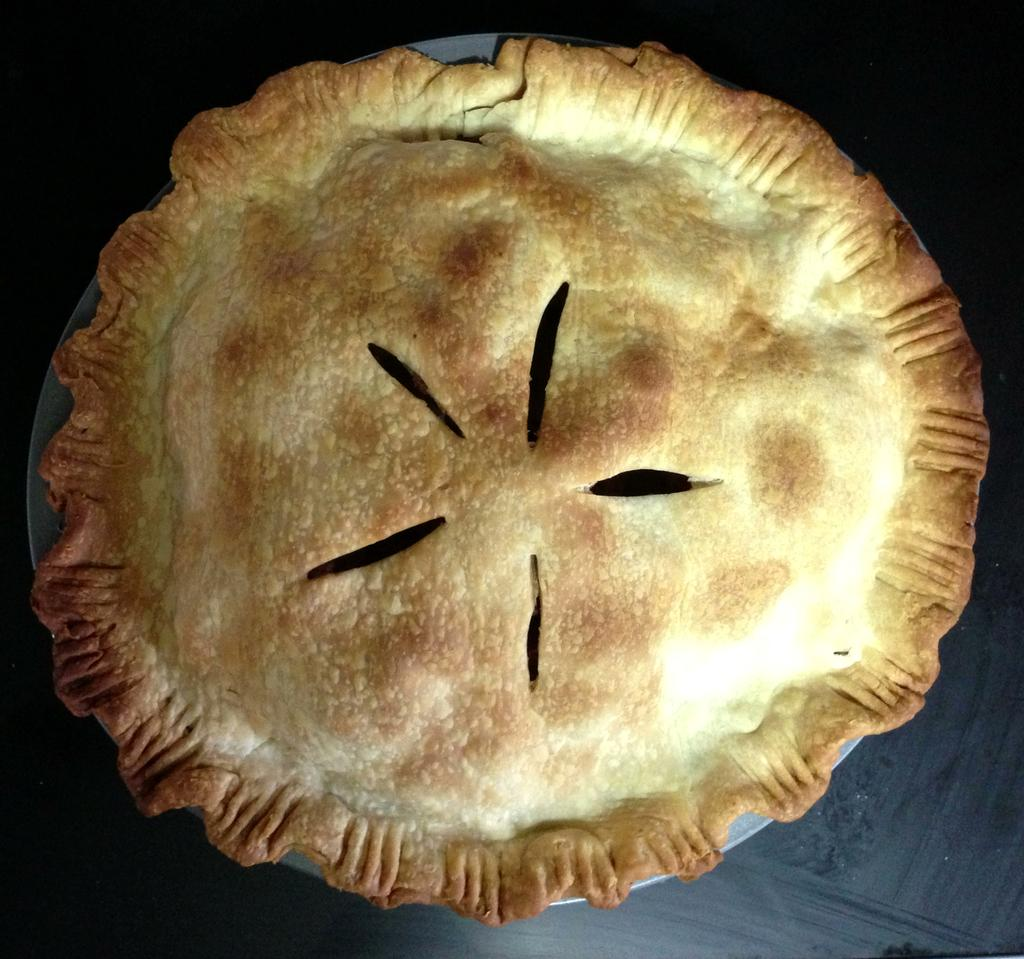What type of food can be seen in the image? The food in the image is in a bowl. What is the color of the food in the image? The food is brown in color. What can be seen in the background of the image? The background of the image is dark. What type of mind can be seen in the image? There is no mind present in the image; it features food in a bowl. How does the brake function in the image? There is no brake present in the image; it is a picture of food in a bowl. 